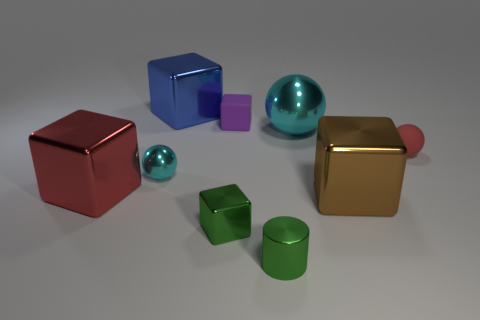Subtract all tiny green metallic cubes. How many cubes are left? 4 Subtract 1 blocks. How many blocks are left? 4 Subtract all purple cubes. How many cubes are left? 4 Subtract all brown cubes. Subtract all purple cylinders. How many cubes are left? 4 Subtract all cubes. How many objects are left? 4 Subtract 1 green cubes. How many objects are left? 8 Subtract all big metallic cubes. Subtract all big cubes. How many objects are left? 3 Add 3 big shiny blocks. How many big shiny blocks are left? 6 Add 8 red rubber objects. How many red rubber objects exist? 9 